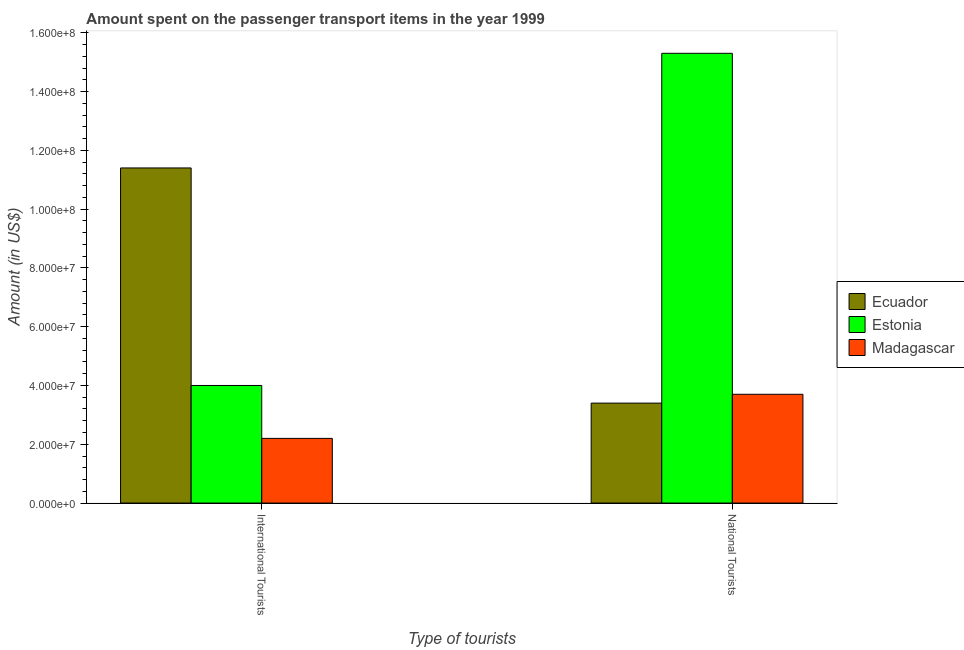What is the label of the 1st group of bars from the left?
Make the answer very short. International Tourists. What is the amount spent on transport items of international tourists in Madagascar?
Offer a very short reply. 2.20e+07. Across all countries, what is the maximum amount spent on transport items of international tourists?
Offer a terse response. 1.14e+08. Across all countries, what is the minimum amount spent on transport items of national tourists?
Your response must be concise. 3.40e+07. In which country was the amount spent on transport items of international tourists maximum?
Keep it short and to the point. Ecuador. In which country was the amount spent on transport items of international tourists minimum?
Make the answer very short. Madagascar. What is the total amount spent on transport items of national tourists in the graph?
Provide a short and direct response. 2.24e+08. What is the difference between the amount spent on transport items of national tourists in Ecuador and that in Madagascar?
Offer a very short reply. -3.00e+06. What is the difference between the amount spent on transport items of international tourists in Madagascar and the amount spent on transport items of national tourists in Estonia?
Your answer should be compact. -1.31e+08. What is the average amount spent on transport items of international tourists per country?
Your response must be concise. 5.87e+07. What is the difference between the amount spent on transport items of national tourists and amount spent on transport items of international tourists in Ecuador?
Provide a short and direct response. -8.00e+07. In how many countries, is the amount spent on transport items of international tourists greater than 76000000 US$?
Offer a terse response. 1. Is the amount spent on transport items of international tourists in Madagascar less than that in Estonia?
Your response must be concise. Yes. What does the 1st bar from the left in International Tourists represents?
Provide a short and direct response. Ecuador. What does the 3rd bar from the right in National Tourists represents?
Provide a succinct answer. Ecuador. How many bars are there?
Offer a terse response. 6. Are all the bars in the graph horizontal?
Your response must be concise. No. How many countries are there in the graph?
Give a very brief answer. 3. What is the difference between two consecutive major ticks on the Y-axis?
Provide a short and direct response. 2.00e+07. Are the values on the major ticks of Y-axis written in scientific E-notation?
Your answer should be compact. Yes. Does the graph contain grids?
Offer a very short reply. No. How many legend labels are there?
Ensure brevity in your answer.  3. What is the title of the graph?
Keep it short and to the point. Amount spent on the passenger transport items in the year 1999. Does "Monaco" appear as one of the legend labels in the graph?
Offer a terse response. No. What is the label or title of the X-axis?
Provide a succinct answer. Type of tourists. What is the Amount (in US$) in Ecuador in International Tourists?
Give a very brief answer. 1.14e+08. What is the Amount (in US$) in Estonia in International Tourists?
Keep it short and to the point. 4.00e+07. What is the Amount (in US$) in Madagascar in International Tourists?
Offer a terse response. 2.20e+07. What is the Amount (in US$) of Ecuador in National Tourists?
Ensure brevity in your answer.  3.40e+07. What is the Amount (in US$) of Estonia in National Tourists?
Provide a succinct answer. 1.53e+08. What is the Amount (in US$) of Madagascar in National Tourists?
Your response must be concise. 3.70e+07. Across all Type of tourists, what is the maximum Amount (in US$) in Ecuador?
Make the answer very short. 1.14e+08. Across all Type of tourists, what is the maximum Amount (in US$) in Estonia?
Make the answer very short. 1.53e+08. Across all Type of tourists, what is the maximum Amount (in US$) of Madagascar?
Your answer should be very brief. 3.70e+07. Across all Type of tourists, what is the minimum Amount (in US$) in Ecuador?
Ensure brevity in your answer.  3.40e+07. Across all Type of tourists, what is the minimum Amount (in US$) in Estonia?
Your answer should be compact. 4.00e+07. Across all Type of tourists, what is the minimum Amount (in US$) of Madagascar?
Offer a very short reply. 2.20e+07. What is the total Amount (in US$) in Ecuador in the graph?
Offer a very short reply. 1.48e+08. What is the total Amount (in US$) of Estonia in the graph?
Offer a very short reply. 1.93e+08. What is the total Amount (in US$) in Madagascar in the graph?
Provide a short and direct response. 5.90e+07. What is the difference between the Amount (in US$) of Ecuador in International Tourists and that in National Tourists?
Your response must be concise. 8.00e+07. What is the difference between the Amount (in US$) of Estonia in International Tourists and that in National Tourists?
Your response must be concise. -1.13e+08. What is the difference between the Amount (in US$) in Madagascar in International Tourists and that in National Tourists?
Ensure brevity in your answer.  -1.50e+07. What is the difference between the Amount (in US$) in Ecuador in International Tourists and the Amount (in US$) in Estonia in National Tourists?
Ensure brevity in your answer.  -3.90e+07. What is the difference between the Amount (in US$) in Ecuador in International Tourists and the Amount (in US$) in Madagascar in National Tourists?
Provide a succinct answer. 7.70e+07. What is the average Amount (in US$) in Ecuador per Type of tourists?
Offer a terse response. 7.40e+07. What is the average Amount (in US$) in Estonia per Type of tourists?
Provide a short and direct response. 9.65e+07. What is the average Amount (in US$) of Madagascar per Type of tourists?
Give a very brief answer. 2.95e+07. What is the difference between the Amount (in US$) in Ecuador and Amount (in US$) in Estonia in International Tourists?
Your answer should be compact. 7.40e+07. What is the difference between the Amount (in US$) in Ecuador and Amount (in US$) in Madagascar in International Tourists?
Keep it short and to the point. 9.20e+07. What is the difference between the Amount (in US$) in Estonia and Amount (in US$) in Madagascar in International Tourists?
Offer a terse response. 1.80e+07. What is the difference between the Amount (in US$) of Ecuador and Amount (in US$) of Estonia in National Tourists?
Your response must be concise. -1.19e+08. What is the difference between the Amount (in US$) of Estonia and Amount (in US$) of Madagascar in National Tourists?
Provide a short and direct response. 1.16e+08. What is the ratio of the Amount (in US$) in Ecuador in International Tourists to that in National Tourists?
Give a very brief answer. 3.35. What is the ratio of the Amount (in US$) in Estonia in International Tourists to that in National Tourists?
Your response must be concise. 0.26. What is the ratio of the Amount (in US$) in Madagascar in International Tourists to that in National Tourists?
Provide a succinct answer. 0.59. What is the difference between the highest and the second highest Amount (in US$) of Ecuador?
Make the answer very short. 8.00e+07. What is the difference between the highest and the second highest Amount (in US$) in Estonia?
Provide a succinct answer. 1.13e+08. What is the difference between the highest and the second highest Amount (in US$) in Madagascar?
Provide a short and direct response. 1.50e+07. What is the difference between the highest and the lowest Amount (in US$) of Ecuador?
Provide a succinct answer. 8.00e+07. What is the difference between the highest and the lowest Amount (in US$) of Estonia?
Ensure brevity in your answer.  1.13e+08. What is the difference between the highest and the lowest Amount (in US$) in Madagascar?
Provide a succinct answer. 1.50e+07. 